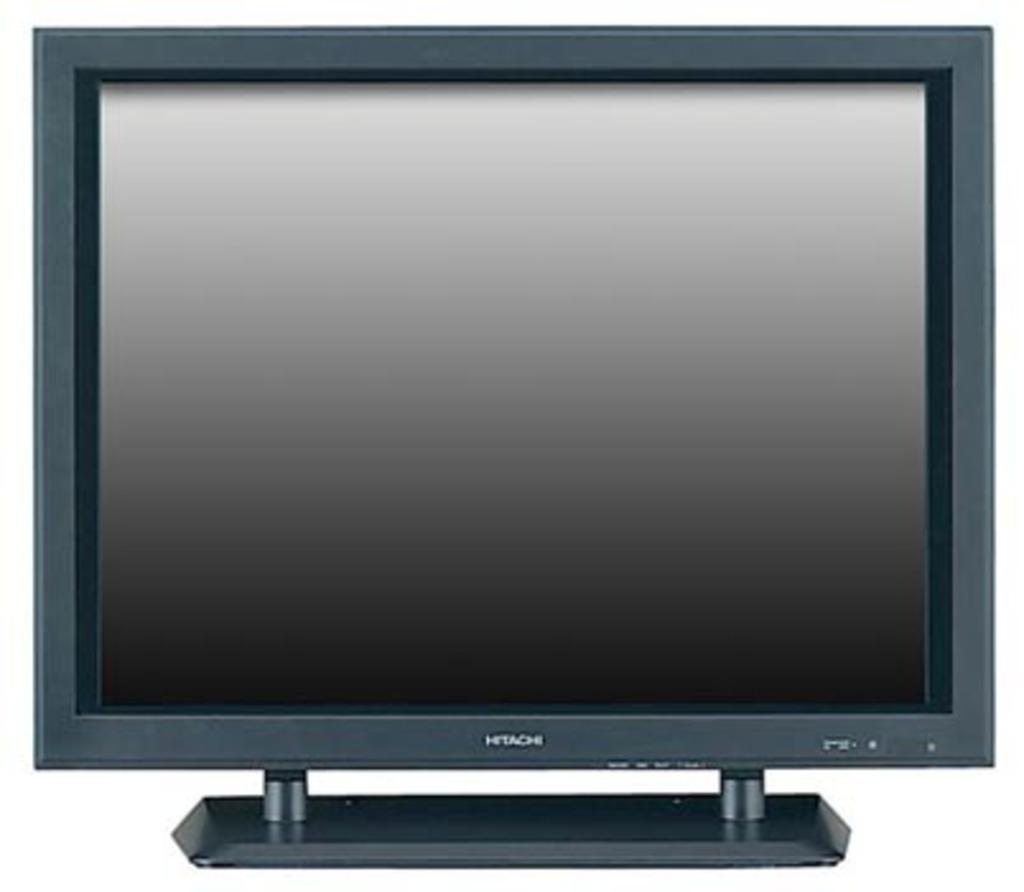<image>
Describe the image concisely. HITACHI monitor which is grey with a desk stand and flat screen. 